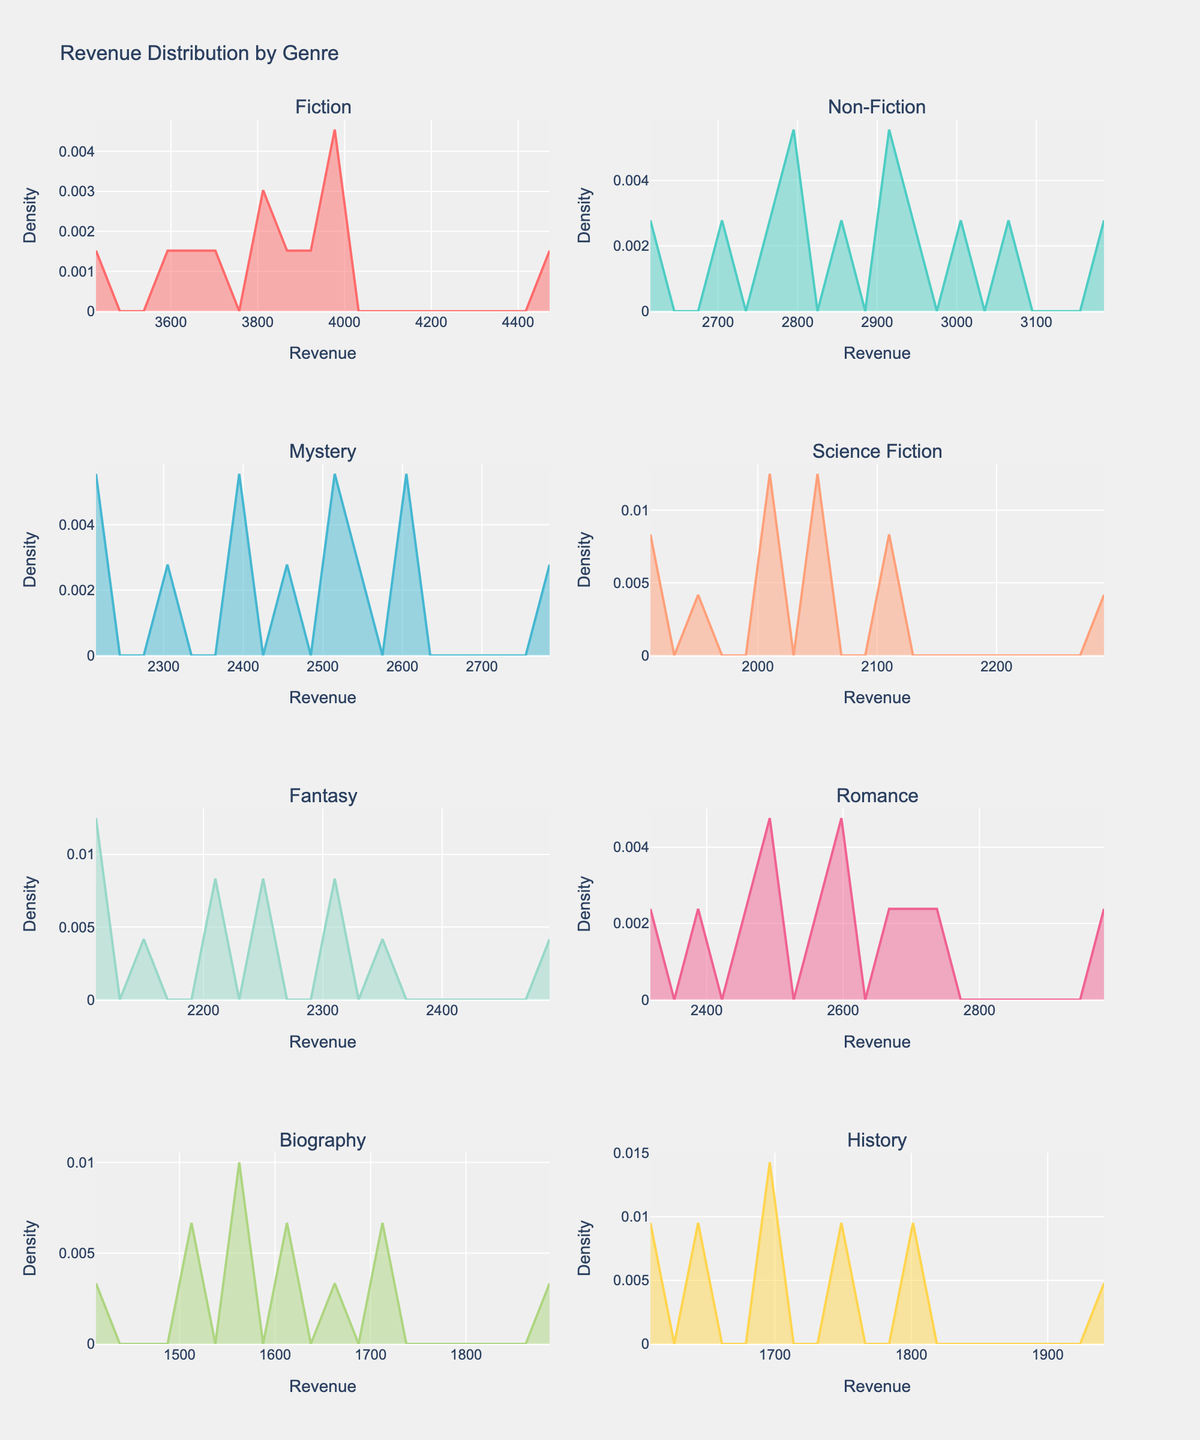What is the title of the figure? The title is located at the top center of the figure and is commonly used to describe what the figure is depicting.
Answer: Revenue Distribution by Genre Which genre has the highest peak in its density plot? The density plot's peak indicates the mode (most frequent value). By visually comparing the peaks across all subplots, we see that Fiction shows the highest peak.
Answer: Fiction How does the density of Science Fiction compare between the revenue range of 2000 and 3000? By inspecting the Science Fiction subplot, we observe that the density is generally lower compared to some other genres. The curve within the 2000-3000 range is relatively flat compared to genres such as Romance or Fiction.
Answer: Lower Which genre has the widest spread in revenue distribution? The widest spread in the density plots can be identified by looking at the range over which the density curve extends. In this case, Fiction appears to have the widest spread, as its curve spans a larger range of revenue values.
Answer: Fiction Is there any genre whose revenue is consistently above 1500 across all months? By examining the minimum revenue points on the density plots for each genre, none of the genres show all revenues consistently above 1500, but Fiction and Romance are close to maintaining this.
Answer: No What is the common range of revenues where most genres have significant density? By observing the x-axis ranges where most density plots have higher values, it seems that the range between 2000 and 3000 is common for many genres.
Answer: 2000-3000 Which genre shows the least density variation across different revenue levels? The least variation is indicated by a dense, narrow peak without wide spread. Biography has relatively consistent but low density, indicating less variation.
Answer: Biography During which revenue range does the Romance genre achieve its highest density? By inspecting the Romance subplot, its highest peak occurs around the revenue value of 2500.
Answer: 2500 Compare the density peaks of Fantasy and History genres. Which one has a higher peak and by what visual difference? By visually comparing the subplots for Fantasy and History, Fantasy has a slightly higher peak than History. The visual difference shows Fantasy's peak is clearly discernible above History's peak.
Answer: Fantasy, slightly higher 